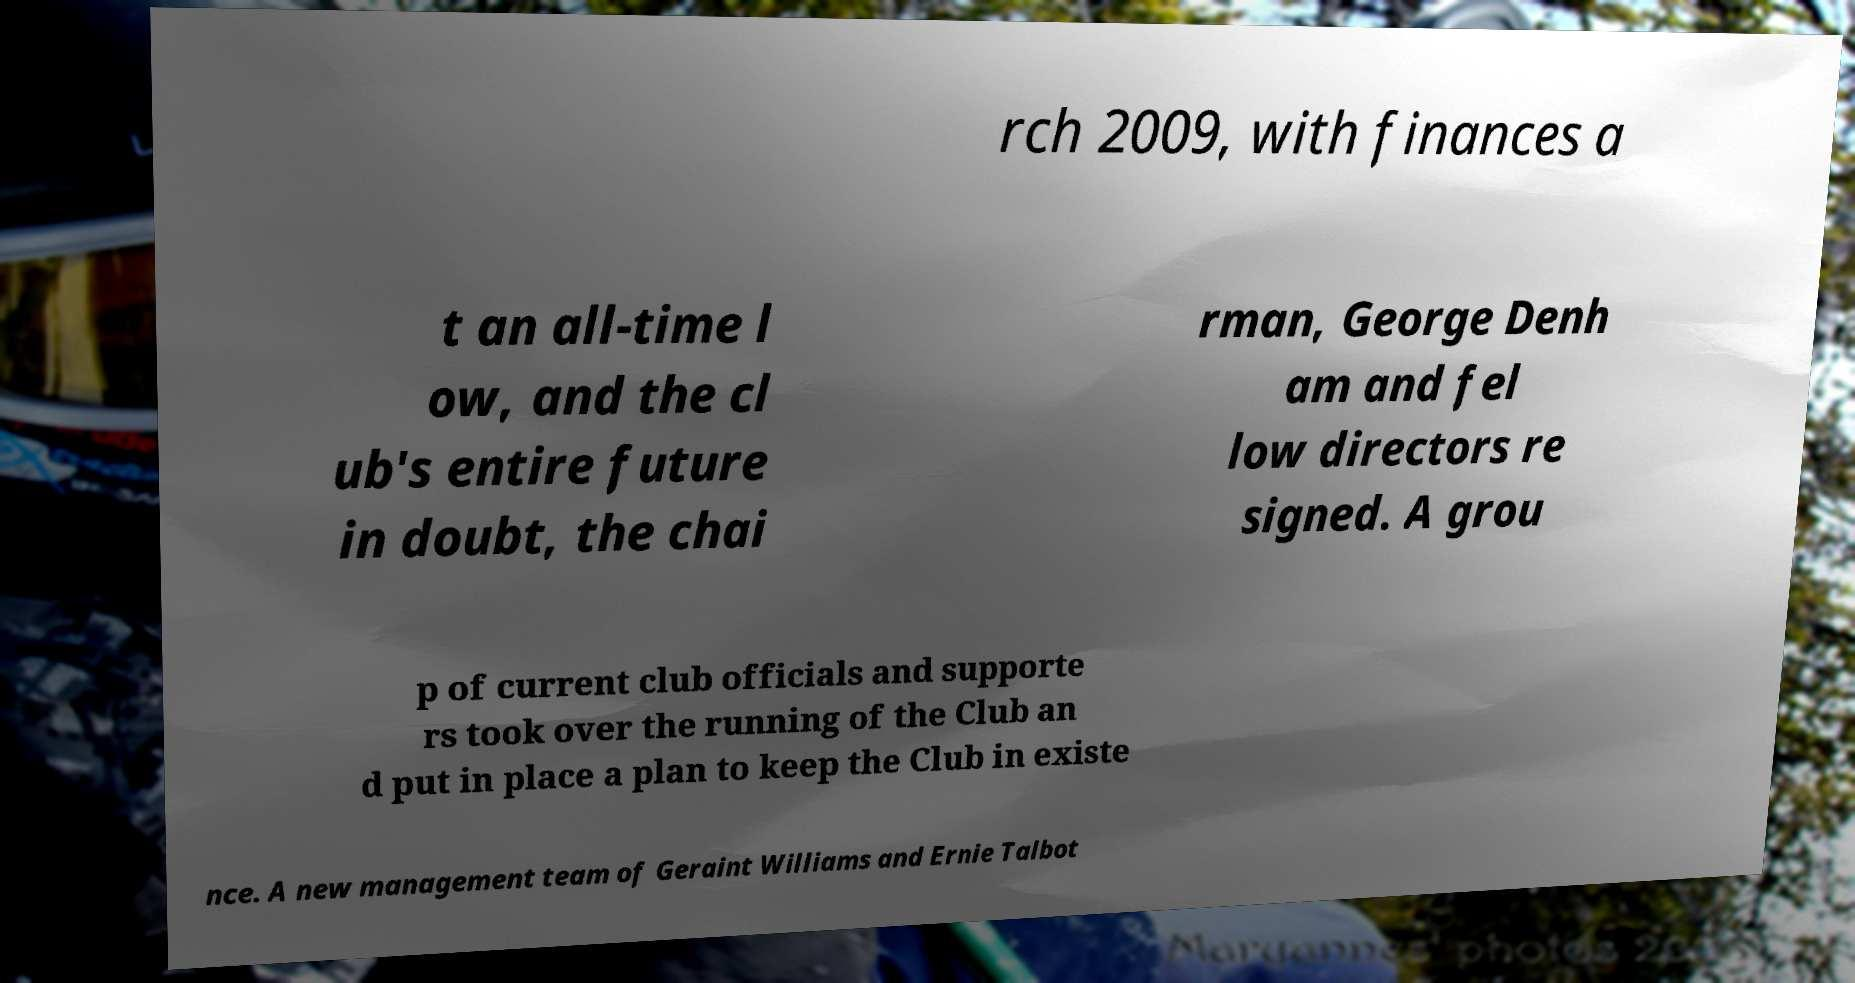For documentation purposes, I need the text within this image transcribed. Could you provide that? rch 2009, with finances a t an all-time l ow, and the cl ub's entire future in doubt, the chai rman, George Denh am and fel low directors re signed. A grou p of current club officials and supporte rs took over the running of the Club an d put in place a plan to keep the Club in existe nce. A new management team of Geraint Williams and Ernie Talbot 